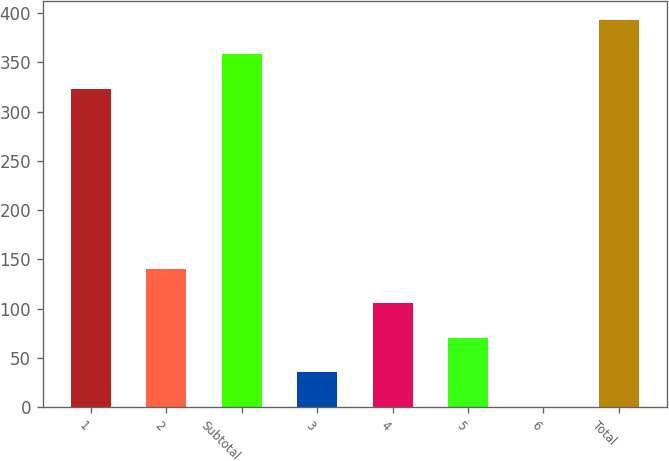<chart> <loc_0><loc_0><loc_500><loc_500><bar_chart><fcel>1<fcel>2<fcel>Subtotal<fcel>3<fcel>4<fcel>5<fcel>6<fcel>Total<nl><fcel>323<fcel>140.47<fcel>358.09<fcel>35.2<fcel>105.38<fcel>70.29<fcel>0.11<fcel>393.18<nl></chart> 